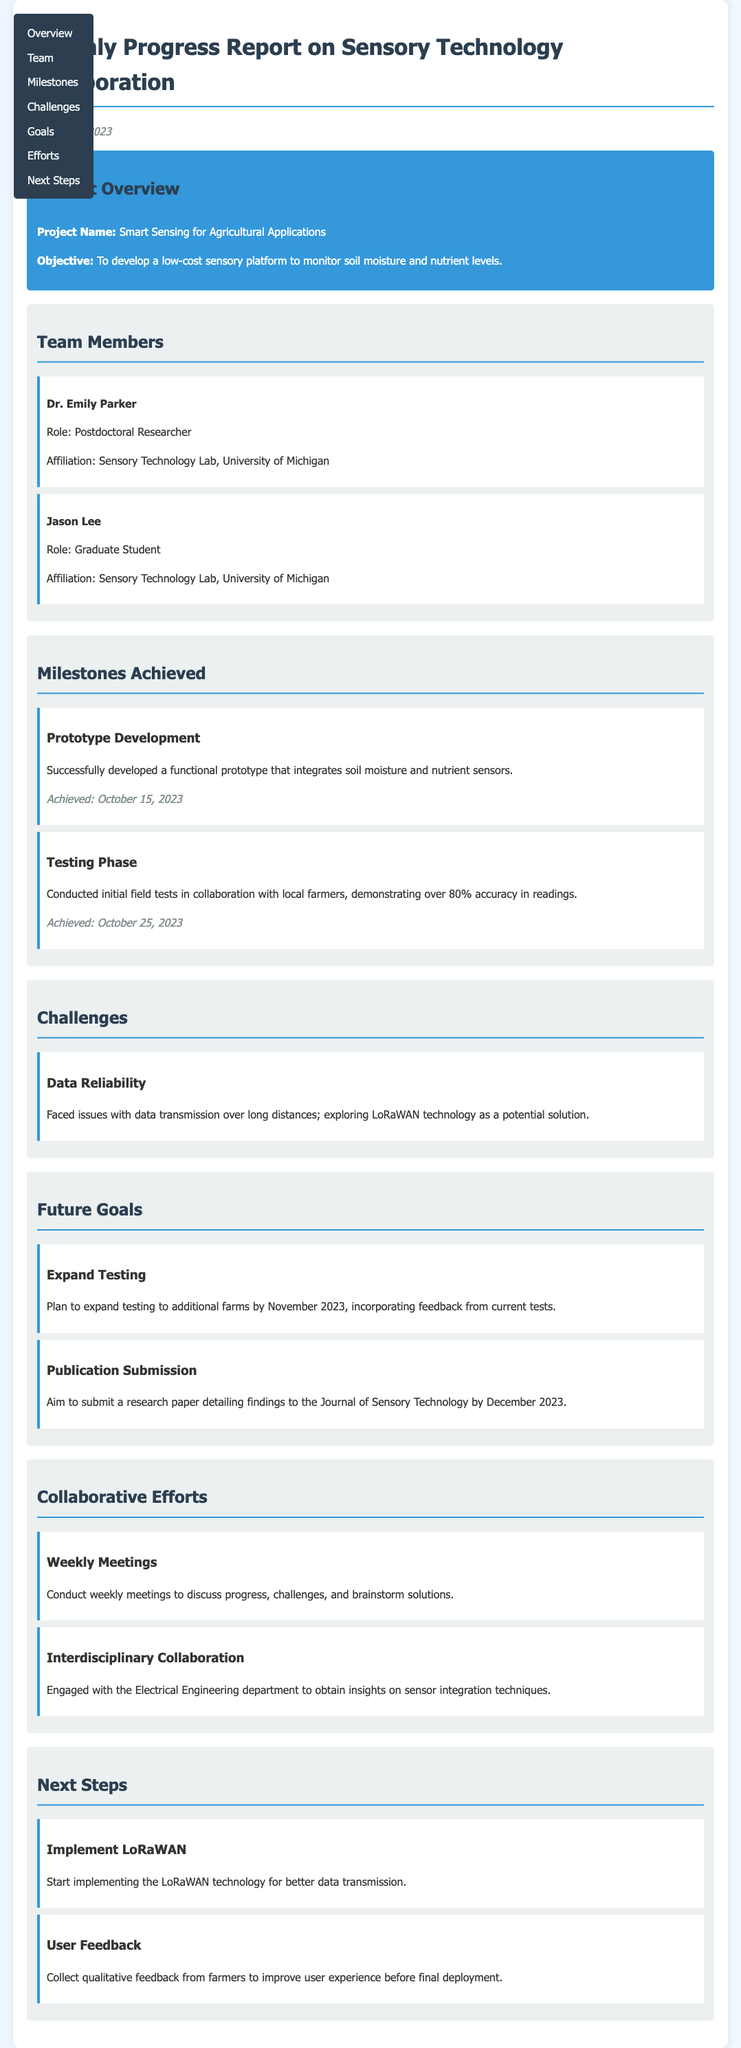what is the project name? The project name is stated in the document under the Project Overview section.
Answer: Smart Sensing for Agricultural Applications who is the postdoctoral researcher? The document lists team members along with their roles, where Dr. Emily Parker is identified as the postdoctoral researcher.
Answer: Dr. Emily Parker what date was the prototype developed? The achievement date for the prototype development is mentioned in the Milestones Achieved section.
Answer: October 15, 2023 what percentage accuracy was demonstrated in initial field tests? This information is provided in the description of the Testing Phase milestone.
Answer: over 80% what are the two future goals mentioned? The document outlines future goals in a dedicated section, which includes two specific goals.
Answer: Expand Testing, Publication Submission what challenge is being addressed in the project? The Challenges section describes the specific issue being faced, which involves data transmission.
Answer: Data Reliability how often do team members conduct meetings? The frequency of meetings is mentioned in the Collaborative Efforts section, highlighting the team's engagement.
Answer: weekly what technology is being explored for better data transmission? The document specifies the technology being investigated in response to a challenge in the Challenges section.
Answer: LoRaWAN what is one key next step identified in the report? The Next Steps section highlights actions the team plans to take, indicating key tasks for the upcoming period.
Answer: Implement LoRaWAN 